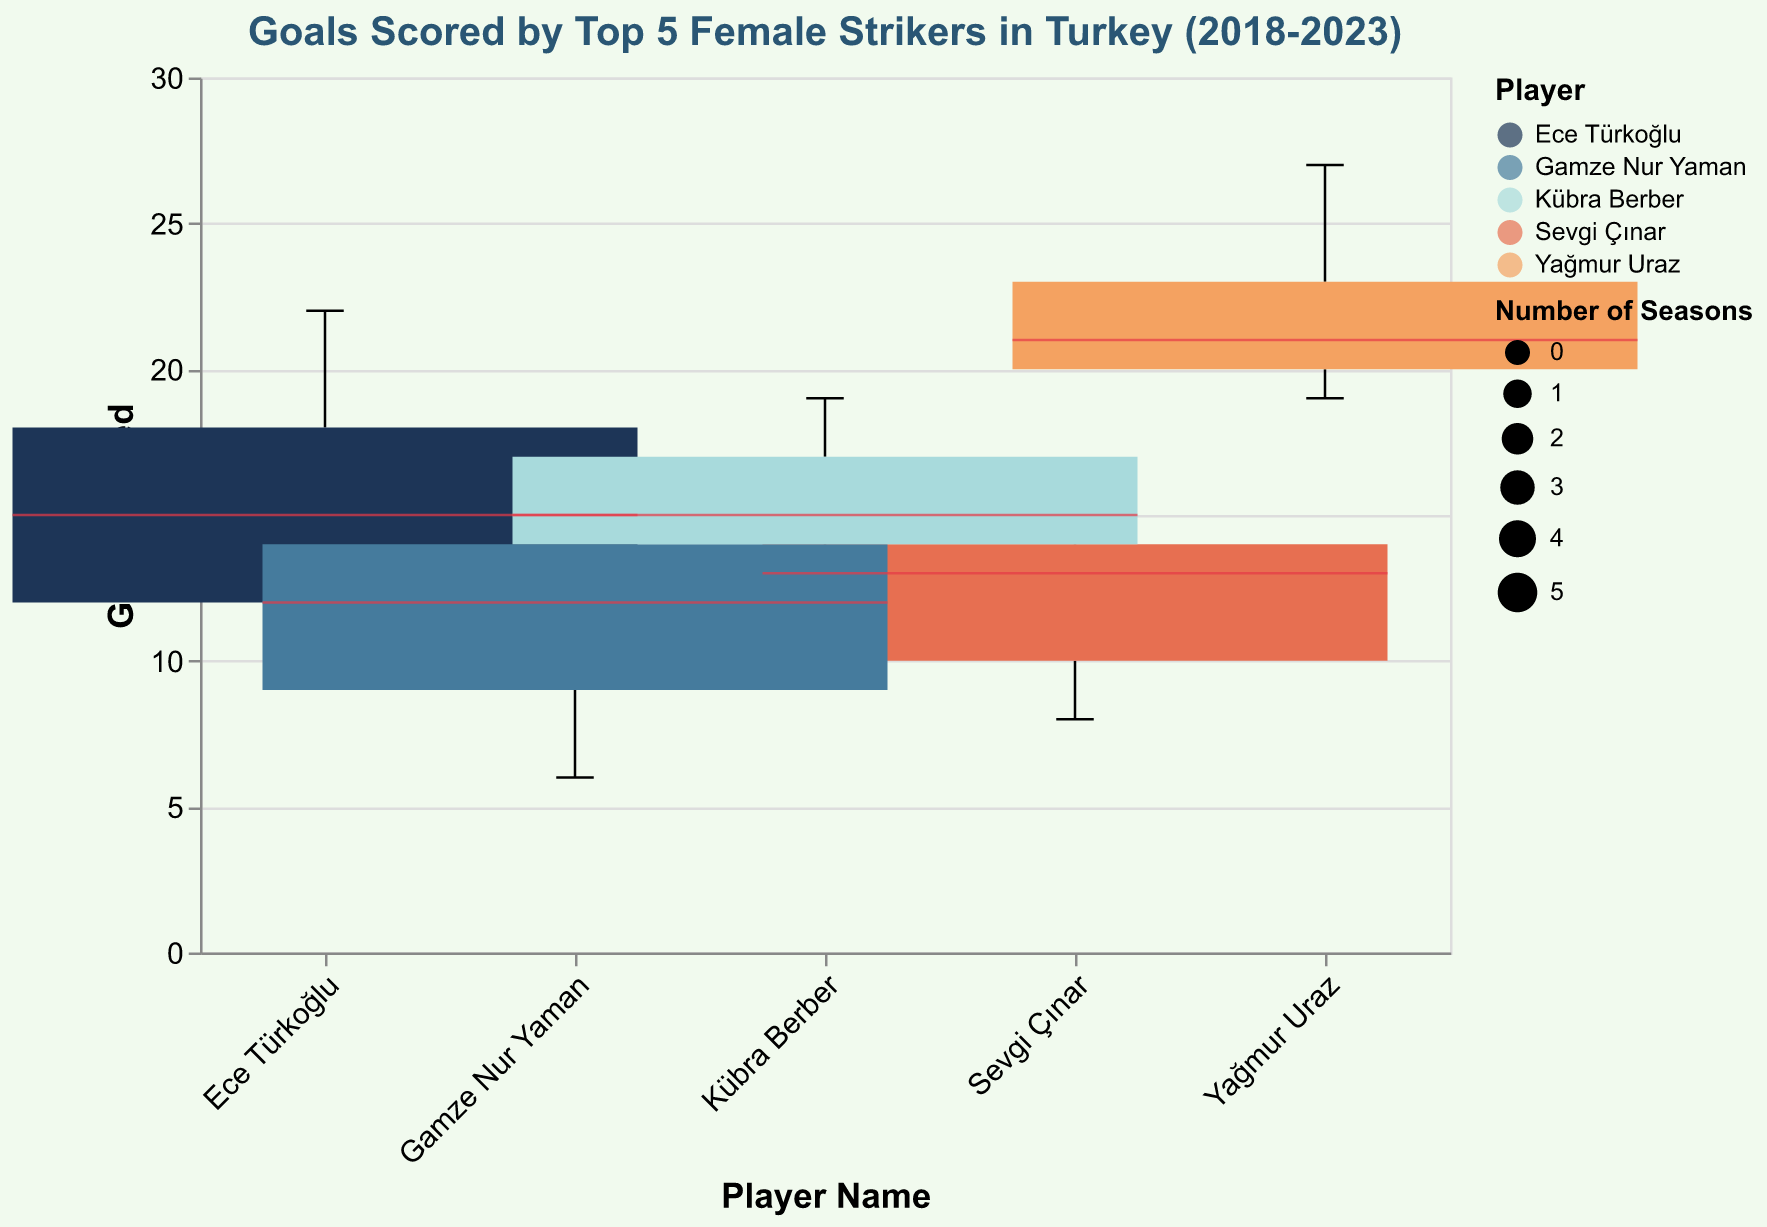What is the title of the figure? The title of the figure is usually displayed at the top center of the chart area. In this case, you can directly read it from the top of the figure.
Answer: Goals Scored by Top 5 Female Strikers in Turkey (2018-2023) Who scored the most goals overall during the last five seasons? To find the player with the most goals overall, look at the box plots and identify the highest boxplot which represents the maximum values.
Answer: Yağmur Uraz What are the range and median of goals for Ece Türkoğlu? Look at the box plot for Ece Türkoğlu: the range is from the minimum to the maximum goals, and the median is depicted by a line within the box.
Answer: Range: 11 to 22, Median: 15 Which player has the most consistent performance (smallest interquartile range)? Find the player whose box plot has the smallest distance between the bottom (Q1) and top (Q3) parts of the box.
Answer: Sevgi Çınar How many seasons are displayed for Gamze Nur Yaman? The number of seasons is depicted by the width of the box plot; wider boxes indicate more seasons.
Answer: 5 Which player's goal count varies the most across seasons? Identify the box plot with the largest total height (min to max) as this represents the largest variability in goals.
Answer: Ece Türkoğlu What is the highest single-season goal count and who achieved it? Look at all the box plots and find the highest single value indicated by the whiskers or outliers.
Answer: 27, Yağmur Uraz What color represents Kübra Berber's data? Each player is represented by a different color; find the legend and locate the color associated with Kübra Berber.
Answer: Orange (assuming this matches "#e76f51") Who scored fewer goals in the 2019-2020 season compared to the previous season? Compare the goal counts for each player between the 2018-2019 and 2019-2020 seasons.
Answer: Sevgi Çınar, Gamze Nur Yaman, Kübra Berber Which player showed a significant improvement in goals from 2020-2021 to 2021-2022? Compare the goal counts for each player between the 2020-2021 and 2021-2022 seasons.
Answer: Ece Türkoğlu 